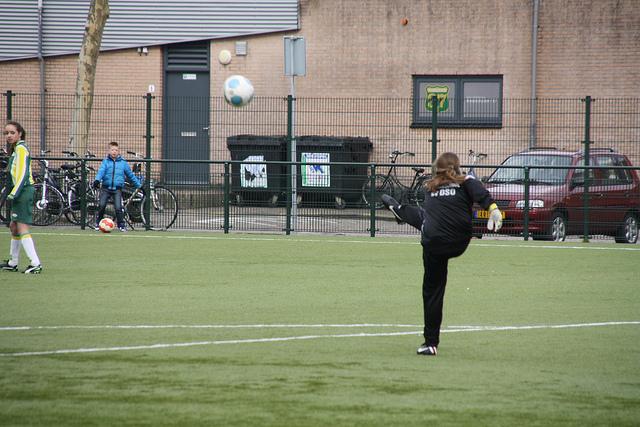Where could a person get snacks?
Write a very short answer. Store. What sport is being played?
Answer briefly. Soccer. What are the children playing?
Quick response, please. Soccer. What is flying through the air?
Be succinct. Ball. What is the style of vehicle by the gate?
Be succinct. Suv. 